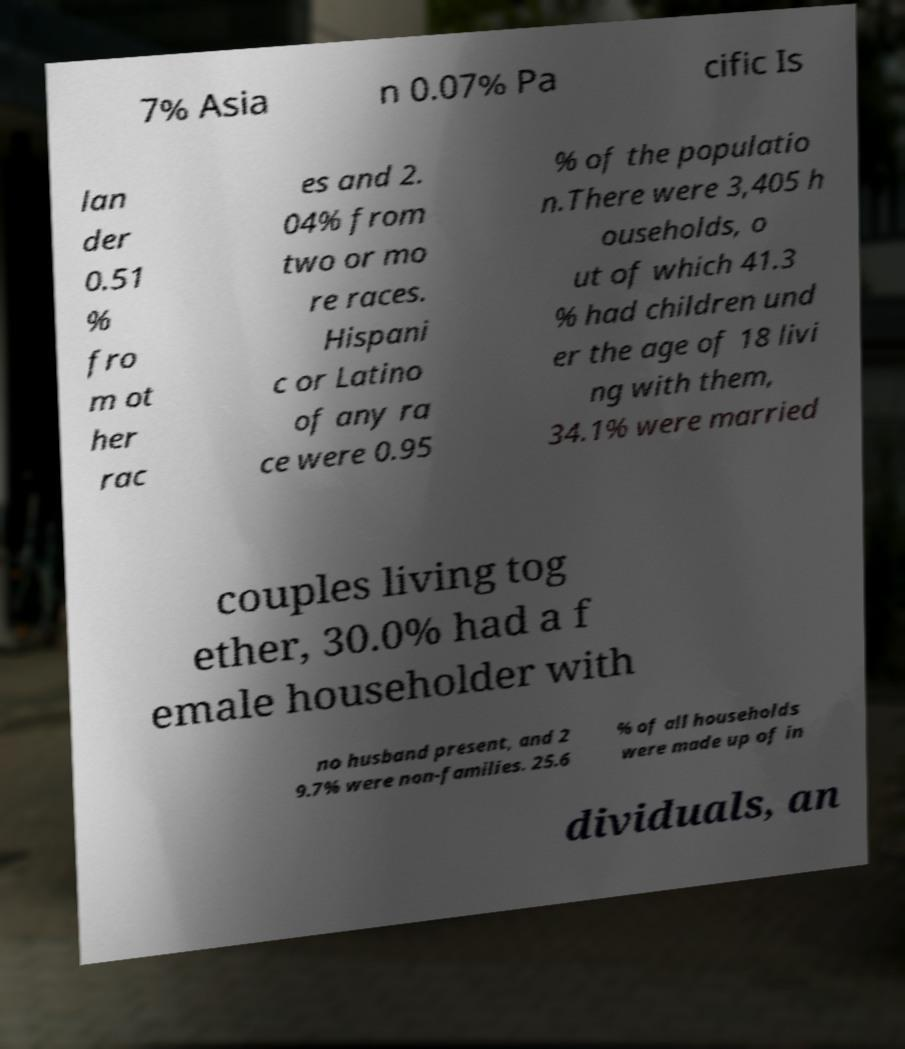What messages or text are displayed in this image? I need them in a readable, typed format. 7% Asia n 0.07% Pa cific Is lan der 0.51 % fro m ot her rac es and 2. 04% from two or mo re races. Hispani c or Latino of any ra ce were 0.95 % of the populatio n.There were 3,405 h ouseholds, o ut of which 41.3 % had children und er the age of 18 livi ng with them, 34.1% were married couples living tog ether, 30.0% had a f emale householder with no husband present, and 2 9.7% were non-families. 25.6 % of all households were made up of in dividuals, an 